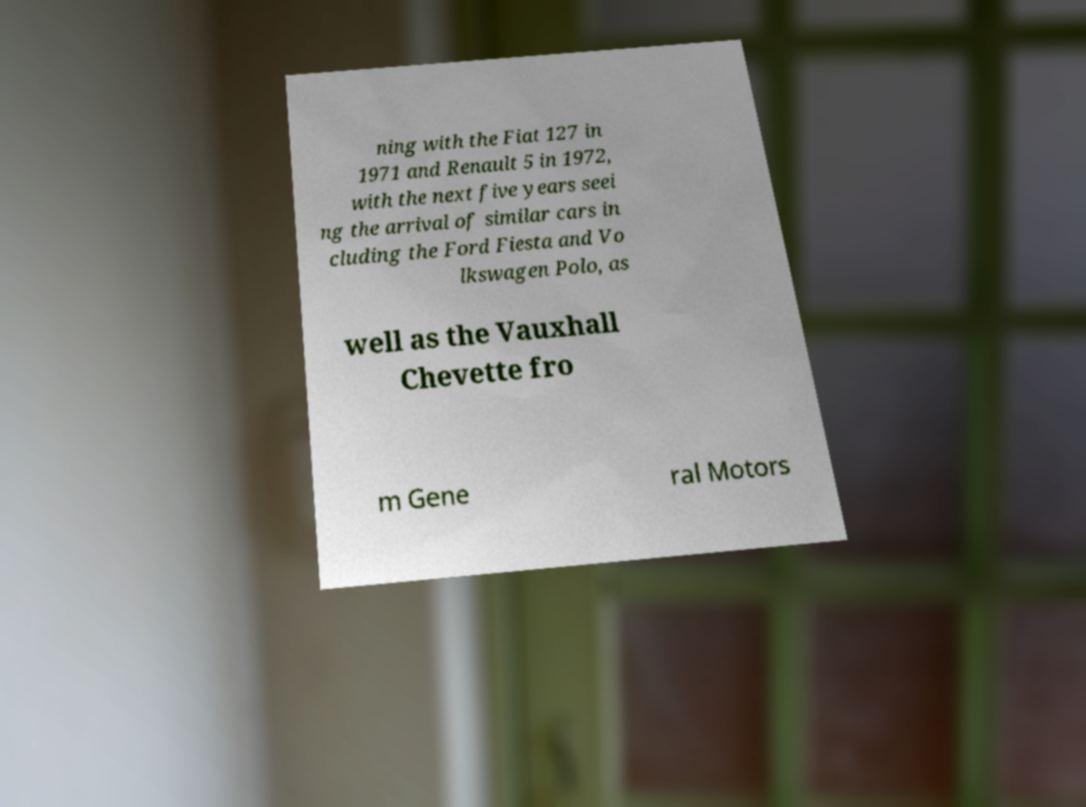Please read and relay the text visible in this image. What does it say? ning with the Fiat 127 in 1971 and Renault 5 in 1972, with the next five years seei ng the arrival of similar cars in cluding the Ford Fiesta and Vo lkswagen Polo, as well as the Vauxhall Chevette fro m Gene ral Motors 